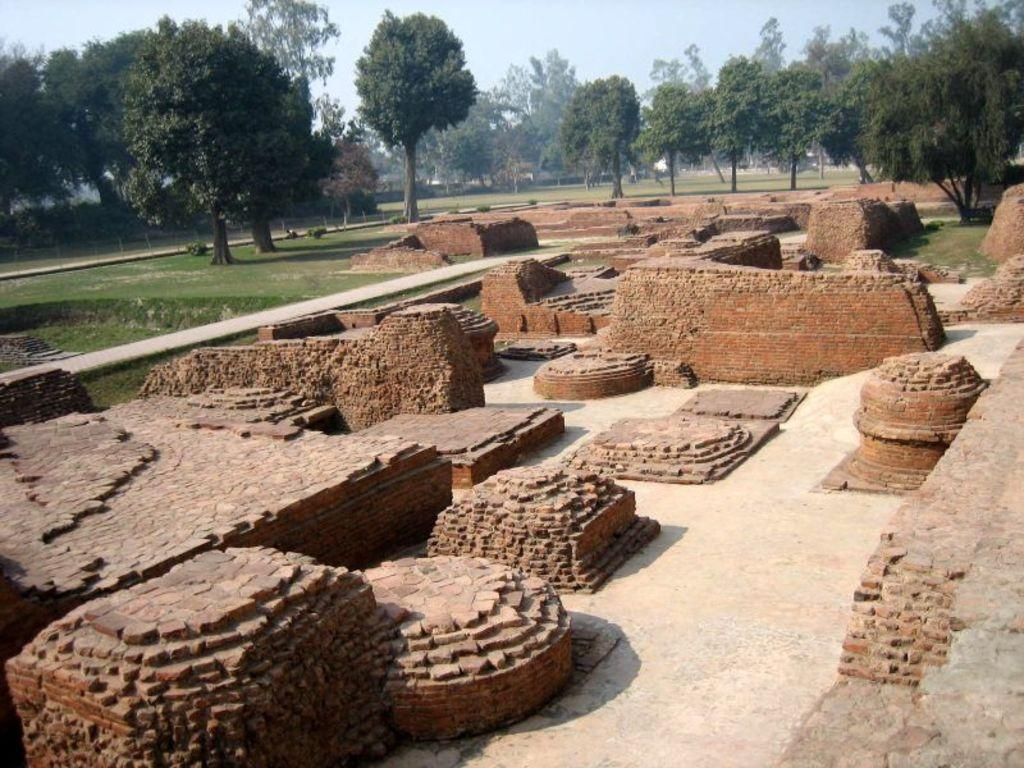What type of material is present in the image? There are bricks in the image. What structures are made of these bricks? There are brick walls in the image. What can be seen in the background of the image? There are trees and the sky visible in the background of the image. What scientific organization is responsible for the construction of the brick walls in the image? There is no information about a scientific organization or the construction of the brick walls in the image. 